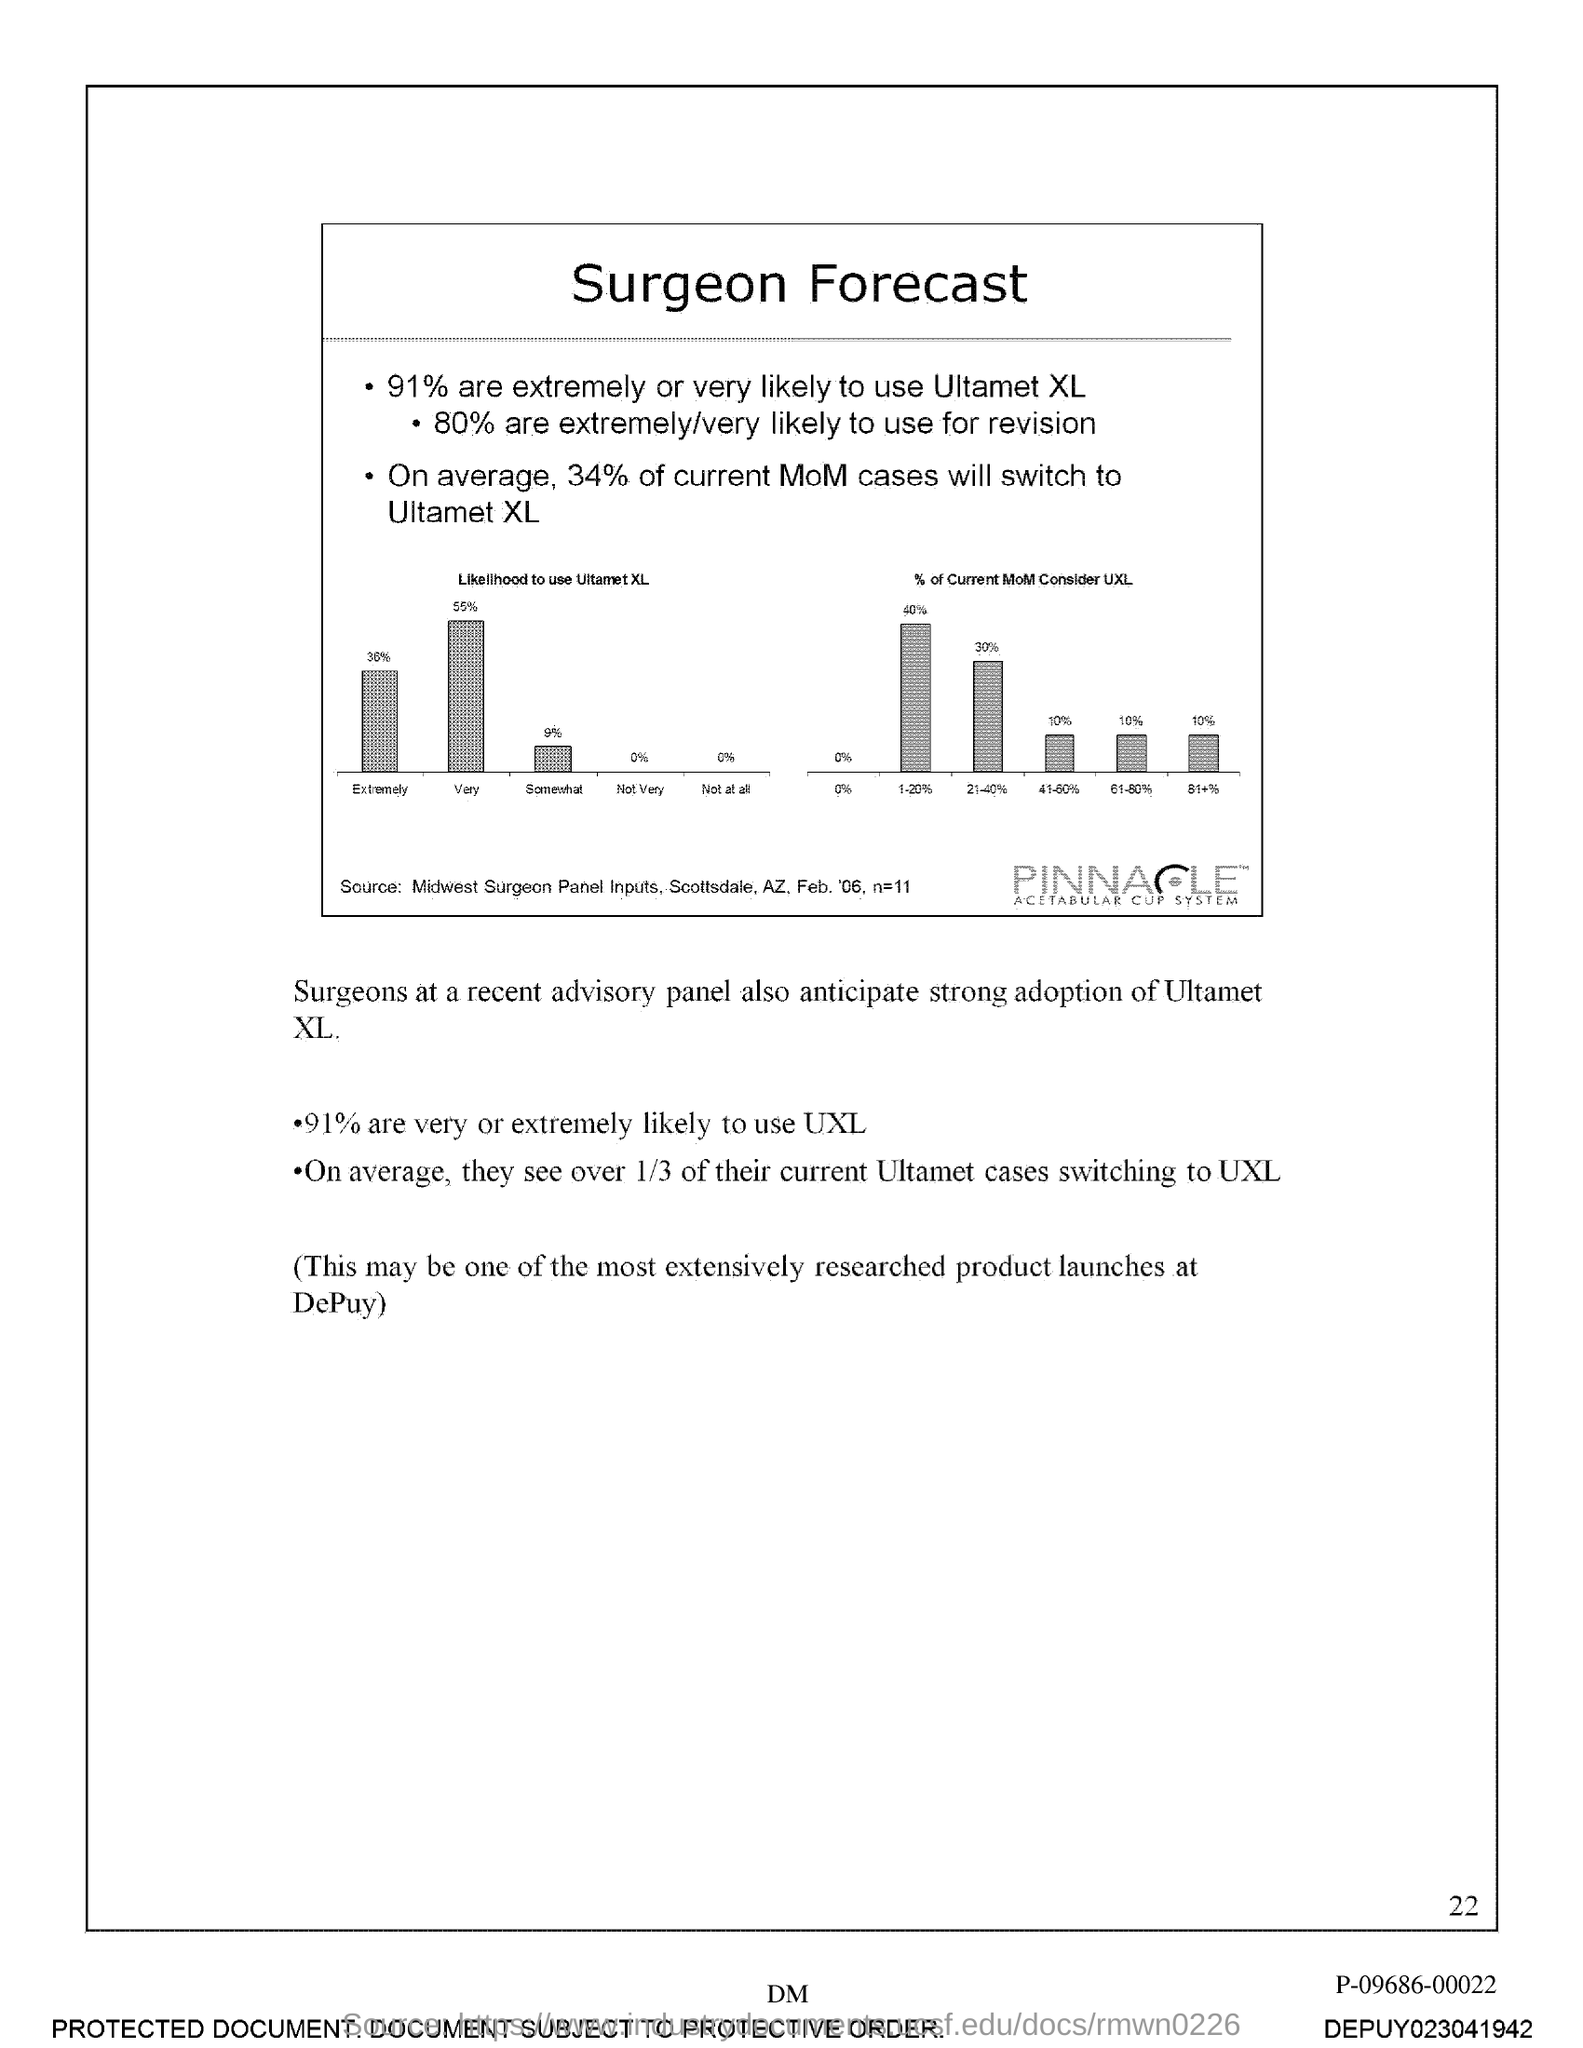Highlight a few significant elements in this photo. The page number is 22, as declared. The title of the document is 'Surgeon Forecast.' 